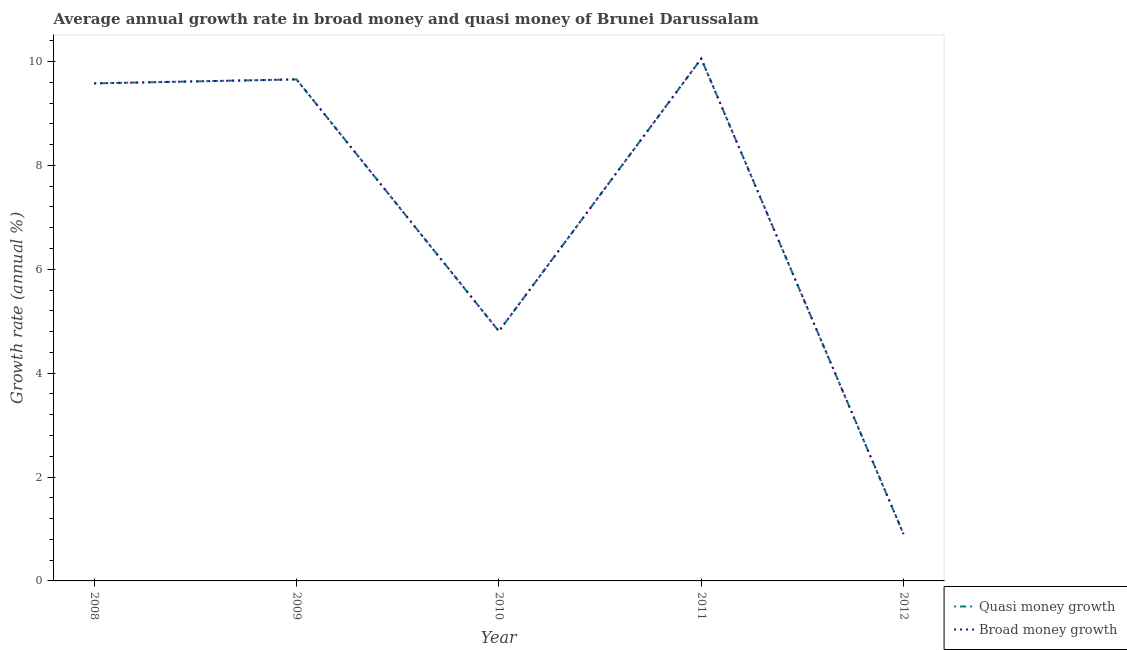How many different coloured lines are there?
Provide a short and direct response. 2. Does the line corresponding to annual growth rate in broad money intersect with the line corresponding to annual growth rate in quasi money?
Keep it short and to the point. Yes. What is the annual growth rate in quasi money in 2009?
Keep it short and to the point. 9.66. Across all years, what is the maximum annual growth rate in broad money?
Make the answer very short. 10.05. Across all years, what is the minimum annual growth rate in quasi money?
Give a very brief answer. 0.9. In which year was the annual growth rate in broad money minimum?
Your response must be concise. 2012. What is the total annual growth rate in quasi money in the graph?
Provide a short and direct response. 35. What is the difference between the annual growth rate in quasi money in 2009 and that in 2011?
Make the answer very short. -0.4. What is the difference between the annual growth rate in broad money in 2008 and the annual growth rate in quasi money in 2009?
Ensure brevity in your answer.  -0.08. What is the average annual growth rate in quasi money per year?
Offer a terse response. 7. What is the ratio of the annual growth rate in broad money in 2008 to that in 2009?
Give a very brief answer. 0.99. Is the annual growth rate in quasi money in 2009 less than that in 2012?
Give a very brief answer. No. What is the difference between the highest and the second highest annual growth rate in quasi money?
Your answer should be very brief. 0.4. What is the difference between the highest and the lowest annual growth rate in broad money?
Your answer should be compact. 9.16. In how many years, is the annual growth rate in quasi money greater than the average annual growth rate in quasi money taken over all years?
Provide a succinct answer. 3. Does the annual growth rate in quasi money monotonically increase over the years?
Your response must be concise. No. Is the annual growth rate in quasi money strictly greater than the annual growth rate in broad money over the years?
Offer a very short reply. No. How many lines are there?
Your answer should be very brief. 2. How many years are there in the graph?
Your response must be concise. 5. Does the graph contain any zero values?
Keep it short and to the point. No. Where does the legend appear in the graph?
Ensure brevity in your answer.  Bottom right. How many legend labels are there?
Offer a terse response. 2. What is the title of the graph?
Your answer should be very brief. Average annual growth rate in broad money and quasi money of Brunei Darussalam. What is the label or title of the X-axis?
Offer a terse response. Year. What is the label or title of the Y-axis?
Your answer should be compact. Growth rate (annual %). What is the Growth rate (annual %) of Quasi money growth in 2008?
Provide a short and direct response. 9.58. What is the Growth rate (annual %) of Broad money growth in 2008?
Offer a very short reply. 9.58. What is the Growth rate (annual %) of Quasi money growth in 2009?
Provide a succinct answer. 9.66. What is the Growth rate (annual %) of Broad money growth in 2009?
Your answer should be very brief. 9.66. What is the Growth rate (annual %) of Quasi money growth in 2010?
Make the answer very short. 4.81. What is the Growth rate (annual %) of Broad money growth in 2010?
Provide a succinct answer. 4.81. What is the Growth rate (annual %) of Quasi money growth in 2011?
Offer a terse response. 10.05. What is the Growth rate (annual %) of Broad money growth in 2011?
Make the answer very short. 10.05. What is the Growth rate (annual %) of Quasi money growth in 2012?
Provide a short and direct response. 0.9. What is the Growth rate (annual %) in Broad money growth in 2012?
Your answer should be compact. 0.9. Across all years, what is the maximum Growth rate (annual %) in Quasi money growth?
Offer a very short reply. 10.05. Across all years, what is the maximum Growth rate (annual %) of Broad money growth?
Make the answer very short. 10.05. Across all years, what is the minimum Growth rate (annual %) of Quasi money growth?
Your answer should be compact. 0.9. Across all years, what is the minimum Growth rate (annual %) in Broad money growth?
Provide a short and direct response. 0.9. What is the total Growth rate (annual %) in Quasi money growth in the graph?
Give a very brief answer. 35. What is the total Growth rate (annual %) of Broad money growth in the graph?
Offer a terse response. 35. What is the difference between the Growth rate (annual %) of Quasi money growth in 2008 and that in 2009?
Keep it short and to the point. -0.08. What is the difference between the Growth rate (annual %) of Broad money growth in 2008 and that in 2009?
Offer a terse response. -0.08. What is the difference between the Growth rate (annual %) in Quasi money growth in 2008 and that in 2010?
Give a very brief answer. 4.77. What is the difference between the Growth rate (annual %) of Broad money growth in 2008 and that in 2010?
Provide a short and direct response. 4.77. What is the difference between the Growth rate (annual %) in Quasi money growth in 2008 and that in 2011?
Provide a succinct answer. -0.48. What is the difference between the Growth rate (annual %) in Broad money growth in 2008 and that in 2011?
Offer a terse response. -0.48. What is the difference between the Growth rate (annual %) of Quasi money growth in 2008 and that in 2012?
Ensure brevity in your answer.  8.68. What is the difference between the Growth rate (annual %) of Broad money growth in 2008 and that in 2012?
Keep it short and to the point. 8.68. What is the difference between the Growth rate (annual %) in Quasi money growth in 2009 and that in 2010?
Ensure brevity in your answer.  4.85. What is the difference between the Growth rate (annual %) in Broad money growth in 2009 and that in 2010?
Keep it short and to the point. 4.85. What is the difference between the Growth rate (annual %) of Quasi money growth in 2009 and that in 2011?
Your response must be concise. -0.4. What is the difference between the Growth rate (annual %) of Broad money growth in 2009 and that in 2011?
Ensure brevity in your answer.  -0.4. What is the difference between the Growth rate (annual %) of Quasi money growth in 2009 and that in 2012?
Your answer should be very brief. 8.76. What is the difference between the Growth rate (annual %) in Broad money growth in 2009 and that in 2012?
Ensure brevity in your answer.  8.76. What is the difference between the Growth rate (annual %) in Quasi money growth in 2010 and that in 2011?
Keep it short and to the point. -5.25. What is the difference between the Growth rate (annual %) in Broad money growth in 2010 and that in 2011?
Your answer should be very brief. -5.25. What is the difference between the Growth rate (annual %) in Quasi money growth in 2010 and that in 2012?
Your answer should be compact. 3.91. What is the difference between the Growth rate (annual %) of Broad money growth in 2010 and that in 2012?
Make the answer very short. 3.91. What is the difference between the Growth rate (annual %) of Quasi money growth in 2011 and that in 2012?
Offer a very short reply. 9.16. What is the difference between the Growth rate (annual %) in Broad money growth in 2011 and that in 2012?
Keep it short and to the point. 9.16. What is the difference between the Growth rate (annual %) of Quasi money growth in 2008 and the Growth rate (annual %) of Broad money growth in 2009?
Offer a terse response. -0.08. What is the difference between the Growth rate (annual %) in Quasi money growth in 2008 and the Growth rate (annual %) in Broad money growth in 2010?
Provide a short and direct response. 4.77. What is the difference between the Growth rate (annual %) in Quasi money growth in 2008 and the Growth rate (annual %) in Broad money growth in 2011?
Offer a very short reply. -0.48. What is the difference between the Growth rate (annual %) of Quasi money growth in 2008 and the Growth rate (annual %) of Broad money growth in 2012?
Keep it short and to the point. 8.68. What is the difference between the Growth rate (annual %) in Quasi money growth in 2009 and the Growth rate (annual %) in Broad money growth in 2010?
Your answer should be compact. 4.85. What is the difference between the Growth rate (annual %) in Quasi money growth in 2009 and the Growth rate (annual %) in Broad money growth in 2011?
Provide a short and direct response. -0.4. What is the difference between the Growth rate (annual %) of Quasi money growth in 2009 and the Growth rate (annual %) of Broad money growth in 2012?
Your answer should be compact. 8.76. What is the difference between the Growth rate (annual %) of Quasi money growth in 2010 and the Growth rate (annual %) of Broad money growth in 2011?
Provide a short and direct response. -5.25. What is the difference between the Growth rate (annual %) in Quasi money growth in 2010 and the Growth rate (annual %) in Broad money growth in 2012?
Your answer should be very brief. 3.91. What is the difference between the Growth rate (annual %) of Quasi money growth in 2011 and the Growth rate (annual %) of Broad money growth in 2012?
Make the answer very short. 9.16. What is the average Growth rate (annual %) in Quasi money growth per year?
Your response must be concise. 7. What is the average Growth rate (annual %) of Broad money growth per year?
Offer a terse response. 7. In the year 2010, what is the difference between the Growth rate (annual %) of Quasi money growth and Growth rate (annual %) of Broad money growth?
Give a very brief answer. 0. In the year 2012, what is the difference between the Growth rate (annual %) of Quasi money growth and Growth rate (annual %) of Broad money growth?
Keep it short and to the point. 0. What is the ratio of the Growth rate (annual %) of Quasi money growth in 2008 to that in 2009?
Keep it short and to the point. 0.99. What is the ratio of the Growth rate (annual %) of Broad money growth in 2008 to that in 2009?
Keep it short and to the point. 0.99. What is the ratio of the Growth rate (annual %) in Quasi money growth in 2008 to that in 2010?
Offer a very short reply. 1.99. What is the ratio of the Growth rate (annual %) in Broad money growth in 2008 to that in 2010?
Your response must be concise. 1.99. What is the ratio of the Growth rate (annual %) in Quasi money growth in 2008 to that in 2011?
Provide a succinct answer. 0.95. What is the ratio of the Growth rate (annual %) of Broad money growth in 2008 to that in 2011?
Your answer should be compact. 0.95. What is the ratio of the Growth rate (annual %) in Quasi money growth in 2008 to that in 2012?
Provide a short and direct response. 10.65. What is the ratio of the Growth rate (annual %) of Broad money growth in 2008 to that in 2012?
Offer a terse response. 10.65. What is the ratio of the Growth rate (annual %) in Quasi money growth in 2009 to that in 2010?
Your answer should be very brief. 2.01. What is the ratio of the Growth rate (annual %) of Broad money growth in 2009 to that in 2010?
Ensure brevity in your answer.  2.01. What is the ratio of the Growth rate (annual %) in Quasi money growth in 2009 to that in 2011?
Keep it short and to the point. 0.96. What is the ratio of the Growth rate (annual %) in Broad money growth in 2009 to that in 2011?
Offer a very short reply. 0.96. What is the ratio of the Growth rate (annual %) in Quasi money growth in 2009 to that in 2012?
Provide a short and direct response. 10.74. What is the ratio of the Growth rate (annual %) of Broad money growth in 2009 to that in 2012?
Offer a terse response. 10.74. What is the ratio of the Growth rate (annual %) of Quasi money growth in 2010 to that in 2011?
Provide a succinct answer. 0.48. What is the ratio of the Growth rate (annual %) of Broad money growth in 2010 to that in 2011?
Your answer should be very brief. 0.48. What is the ratio of the Growth rate (annual %) of Quasi money growth in 2010 to that in 2012?
Your response must be concise. 5.35. What is the ratio of the Growth rate (annual %) in Broad money growth in 2010 to that in 2012?
Give a very brief answer. 5.35. What is the ratio of the Growth rate (annual %) in Quasi money growth in 2011 to that in 2012?
Keep it short and to the point. 11.18. What is the ratio of the Growth rate (annual %) in Broad money growth in 2011 to that in 2012?
Offer a very short reply. 11.18. What is the difference between the highest and the second highest Growth rate (annual %) of Quasi money growth?
Ensure brevity in your answer.  0.4. What is the difference between the highest and the second highest Growth rate (annual %) of Broad money growth?
Ensure brevity in your answer.  0.4. What is the difference between the highest and the lowest Growth rate (annual %) of Quasi money growth?
Offer a terse response. 9.16. What is the difference between the highest and the lowest Growth rate (annual %) in Broad money growth?
Offer a very short reply. 9.16. 